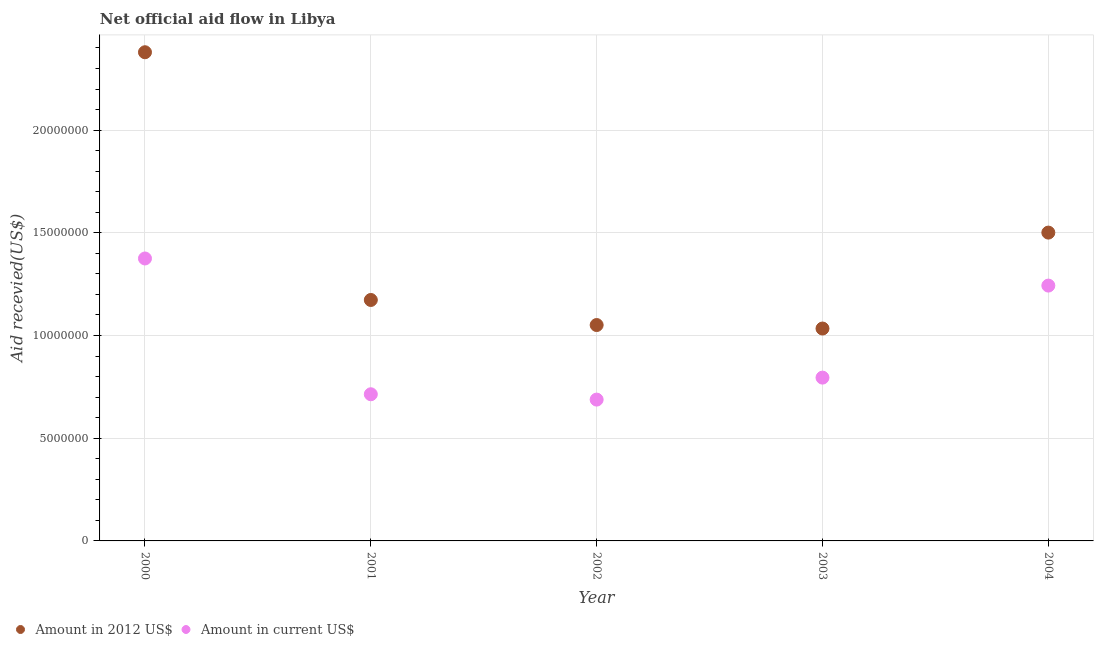How many different coloured dotlines are there?
Give a very brief answer. 2. What is the amount of aid received(expressed in us$) in 2001?
Provide a short and direct response. 7.14e+06. Across all years, what is the maximum amount of aid received(expressed in 2012 us$)?
Your response must be concise. 2.38e+07. Across all years, what is the minimum amount of aid received(expressed in us$)?
Keep it short and to the point. 6.88e+06. In which year was the amount of aid received(expressed in 2012 us$) minimum?
Provide a succinct answer. 2003. What is the total amount of aid received(expressed in us$) in the graph?
Provide a short and direct response. 4.82e+07. What is the difference between the amount of aid received(expressed in 2012 us$) in 2002 and that in 2003?
Offer a terse response. 1.70e+05. What is the difference between the amount of aid received(expressed in us$) in 2000 and the amount of aid received(expressed in 2012 us$) in 2004?
Your answer should be compact. -1.26e+06. What is the average amount of aid received(expressed in us$) per year?
Provide a succinct answer. 9.63e+06. In the year 2003, what is the difference between the amount of aid received(expressed in us$) and amount of aid received(expressed in 2012 us$)?
Offer a terse response. -2.39e+06. In how many years, is the amount of aid received(expressed in 2012 us$) greater than 14000000 US$?
Provide a short and direct response. 2. What is the ratio of the amount of aid received(expressed in 2012 us$) in 2000 to that in 2003?
Provide a short and direct response. 2.3. Is the difference between the amount of aid received(expressed in us$) in 2000 and 2002 greater than the difference between the amount of aid received(expressed in 2012 us$) in 2000 and 2002?
Your answer should be very brief. No. What is the difference between the highest and the second highest amount of aid received(expressed in 2012 us$)?
Give a very brief answer. 8.78e+06. What is the difference between the highest and the lowest amount of aid received(expressed in us$)?
Provide a succinct answer. 6.87e+06. In how many years, is the amount of aid received(expressed in 2012 us$) greater than the average amount of aid received(expressed in 2012 us$) taken over all years?
Make the answer very short. 2. Is the sum of the amount of aid received(expressed in us$) in 2001 and 2002 greater than the maximum amount of aid received(expressed in 2012 us$) across all years?
Give a very brief answer. No. Is the amount of aid received(expressed in 2012 us$) strictly greater than the amount of aid received(expressed in us$) over the years?
Your answer should be compact. Yes. Is the amount of aid received(expressed in 2012 us$) strictly less than the amount of aid received(expressed in us$) over the years?
Ensure brevity in your answer.  No. How many dotlines are there?
Ensure brevity in your answer.  2. Does the graph contain any zero values?
Offer a terse response. No. How many legend labels are there?
Your answer should be very brief. 2. What is the title of the graph?
Your answer should be very brief. Net official aid flow in Libya. Does "Highest 10% of population" appear as one of the legend labels in the graph?
Provide a succinct answer. No. What is the label or title of the X-axis?
Provide a succinct answer. Year. What is the label or title of the Y-axis?
Give a very brief answer. Aid recevied(US$). What is the Aid recevied(US$) in Amount in 2012 US$ in 2000?
Give a very brief answer. 2.38e+07. What is the Aid recevied(US$) of Amount in current US$ in 2000?
Your answer should be compact. 1.38e+07. What is the Aid recevied(US$) in Amount in 2012 US$ in 2001?
Make the answer very short. 1.17e+07. What is the Aid recevied(US$) in Amount in current US$ in 2001?
Your response must be concise. 7.14e+06. What is the Aid recevied(US$) of Amount in 2012 US$ in 2002?
Make the answer very short. 1.05e+07. What is the Aid recevied(US$) of Amount in current US$ in 2002?
Offer a very short reply. 6.88e+06. What is the Aid recevied(US$) in Amount in 2012 US$ in 2003?
Make the answer very short. 1.03e+07. What is the Aid recevied(US$) in Amount in current US$ in 2003?
Offer a very short reply. 7.95e+06. What is the Aid recevied(US$) of Amount in 2012 US$ in 2004?
Ensure brevity in your answer.  1.50e+07. What is the Aid recevied(US$) in Amount in current US$ in 2004?
Provide a short and direct response. 1.24e+07. Across all years, what is the maximum Aid recevied(US$) of Amount in 2012 US$?
Make the answer very short. 2.38e+07. Across all years, what is the maximum Aid recevied(US$) of Amount in current US$?
Make the answer very short. 1.38e+07. Across all years, what is the minimum Aid recevied(US$) in Amount in 2012 US$?
Your response must be concise. 1.03e+07. Across all years, what is the minimum Aid recevied(US$) of Amount in current US$?
Your answer should be compact. 6.88e+06. What is the total Aid recevied(US$) in Amount in 2012 US$ in the graph?
Give a very brief answer. 7.14e+07. What is the total Aid recevied(US$) in Amount in current US$ in the graph?
Keep it short and to the point. 4.82e+07. What is the difference between the Aid recevied(US$) in Amount in 2012 US$ in 2000 and that in 2001?
Your response must be concise. 1.21e+07. What is the difference between the Aid recevied(US$) of Amount in current US$ in 2000 and that in 2001?
Offer a terse response. 6.61e+06. What is the difference between the Aid recevied(US$) of Amount in 2012 US$ in 2000 and that in 2002?
Ensure brevity in your answer.  1.33e+07. What is the difference between the Aid recevied(US$) of Amount in current US$ in 2000 and that in 2002?
Make the answer very short. 6.87e+06. What is the difference between the Aid recevied(US$) of Amount in 2012 US$ in 2000 and that in 2003?
Provide a succinct answer. 1.34e+07. What is the difference between the Aid recevied(US$) of Amount in current US$ in 2000 and that in 2003?
Your answer should be compact. 5.80e+06. What is the difference between the Aid recevied(US$) in Amount in 2012 US$ in 2000 and that in 2004?
Provide a succinct answer. 8.78e+06. What is the difference between the Aid recevied(US$) in Amount in current US$ in 2000 and that in 2004?
Make the answer very short. 1.32e+06. What is the difference between the Aid recevied(US$) in Amount in 2012 US$ in 2001 and that in 2002?
Keep it short and to the point. 1.22e+06. What is the difference between the Aid recevied(US$) of Amount in current US$ in 2001 and that in 2002?
Make the answer very short. 2.60e+05. What is the difference between the Aid recevied(US$) in Amount in 2012 US$ in 2001 and that in 2003?
Your answer should be compact. 1.39e+06. What is the difference between the Aid recevied(US$) of Amount in current US$ in 2001 and that in 2003?
Provide a short and direct response. -8.10e+05. What is the difference between the Aid recevied(US$) of Amount in 2012 US$ in 2001 and that in 2004?
Your answer should be compact. -3.28e+06. What is the difference between the Aid recevied(US$) in Amount in current US$ in 2001 and that in 2004?
Offer a terse response. -5.29e+06. What is the difference between the Aid recevied(US$) of Amount in 2012 US$ in 2002 and that in 2003?
Make the answer very short. 1.70e+05. What is the difference between the Aid recevied(US$) of Amount in current US$ in 2002 and that in 2003?
Your answer should be compact. -1.07e+06. What is the difference between the Aid recevied(US$) of Amount in 2012 US$ in 2002 and that in 2004?
Offer a terse response. -4.50e+06. What is the difference between the Aid recevied(US$) of Amount in current US$ in 2002 and that in 2004?
Ensure brevity in your answer.  -5.55e+06. What is the difference between the Aid recevied(US$) of Amount in 2012 US$ in 2003 and that in 2004?
Make the answer very short. -4.67e+06. What is the difference between the Aid recevied(US$) of Amount in current US$ in 2003 and that in 2004?
Your answer should be compact. -4.48e+06. What is the difference between the Aid recevied(US$) of Amount in 2012 US$ in 2000 and the Aid recevied(US$) of Amount in current US$ in 2001?
Your answer should be compact. 1.66e+07. What is the difference between the Aid recevied(US$) in Amount in 2012 US$ in 2000 and the Aid recevied(US$) in Amount in current US$ in 2002?
Make the answer very short. 1.69e+07. What is the difference between the Aid recevied(US$) in Amount in 2012 US$ in 2000 and the Aid recevied(US$) in Amount in current US$ in 2003?
Provide a succinct answer. 1.58e+07. What is the difference between the Aid recevied(US$) of Amount in 2012 US$ in 2000 and the Aid recevied(US$) of Amount in current US$ in 2004?
Give a very brief answer. 1.14e+07. What is the difference between the Aid recevied(US$) in Amount in 2012 US$ in 2001 and the Aid recevied(US$) in Amount in current US$ in 2002?
Make the answer very short. 4.85e+06. What is the difference between the Aid recevied(US$) in Amount in 2012 US$ in 2001 and the Aid recevied(US$) in Amount in current US$ in 2003?
Your answer should be very brief. 3.78e+06. What is the difference between the Aid recevied(US$) in Amount in 2012 US$ in 2001 and the Aid recevied(US$) in Amount in current US$ in 2004?
Ensure brevity in your answer.  -7.00e+05. What is the difference between the Aid recevied(US$) in Amount in 2012 US$ in 2002 and the Aid recevied(US$) in Amount in current US$ in 2003?
Make the answer very short. 2.56e+06. What is the difference between the Aid recevied(US$) in Amount in 2012 US$ in 2002 and the Aid recevied(US$) in Amount in current US$ in 2004?
Offer a very short reply. -1.92e+06. What is the difference between the Aid recevied(US$) of Amount in 2012 US$ in 2003 and the Aid recevied(US$) of Amount in current US$ in 2004?
Ensure brevity in your answer.  -2.09e+06. What is the average Aid recevied(US$) in Amount in 2012 US$ per year?
Your answer should be very brief. 1.43e+07. What is the average Aid recevied(US$) in Amount in current US$ per year?
Ensure brevity in your answer.  9.63e+06. In the year 2000, what is the difference between the Aid recevied(US$) of Amount in 2012 US$ and Aid recevied(US$) of Amount in current US$?
Offer a very short reply. 1.00e+07. In the year 2001, what is the difference between the Aid recevied(US$) of Amount in 2012 US$ and Aid recevied(US$) of Amount in current US$?
Keep it short and to the point. 4.59e+06. In the year 2002, what is the difference between the Aid recevied(US$) in Amount in 2012 US$ and Aid recevied(US$) in Amount in current US$?
Make the answer very short. 3.63e+06. In the year 2003, what is the difference between the Aid recevied(US$) of Amount in 2012 US$ and Aid recevied(US$) of Amount in current US$?
Keep it short and to the point. 2.39e+06. In the year 2004, what is the difference between the Aid recevied(US$) in Amount in 2012 US$ and Aid recevied(US$) in Amount in current US$?
Your answer should be very brief. 2.58e+06. What is the ratio of the Aid recevied(US$) in Amount in 2012 US$ in 2000 to that in 2001?
Your answer should be compact. 2.03. What is the ratio of the Aid recevied(US$) in Amount in current US$ in 2000 to that in 2001?
Make the answer very short. 1.93. What is the ratio of the Aid recevied(US$) of Amount in 2012 US$ in 2000 to that in 2002?
Make the answer very short. 2.26. What is the ratio of the Aid recevied(US$) of Amount in current US$ in 2000 to that in 2002?
Make the answer very short. 2. What is the ratio of the Aid recevied(US$) in Amount in 2012 US$ in 2000 to that in 2003?
Provide a succinct answer. 2.3. What is the ratio of the Aid recevied(US$) of Amount in current US$ in 2000 to that in 2003?
Your answer should be compact. 1.73. What is the ratio of the Aid recevied(US$) of Amount in 2012 US$ in 2000 to that in 2004?
Provide a short and direct response. 1.58. What is the ratio of the Aid recevied(US$) of Amount in current US$ in 2000 to that in 2004?
Ensure brevity in your answer.  1.11. What is the ratio of the Aid recevied(US$) of Amount in 2012 US$ in 2001 to that in 2002?
Your answer should be compact. 1.12. What is the ratio of the Aid recevied(US$) in Amount in current US$ in 2001 to that in 2002?
Provide a short and direct response. 1.04. What is the ratio of the Aid recevied(US$) of Amount in 2012 US$ in 2001 to that in 2003?
Your response must be concise. 1.13. What is the ratio of the Aid recevied(US$) in Amount in current US$ in 2001 to that in 2003?
Keep it short and to the point. 0.9. What is the ratio of the Aid recevied(US$) in Amount in 2012 US$ in 2001 to that in 2004?
Provide a short and direct response. 0.78. What is the ratio of the Aid recevied(US$) in Amount in current US$ in 2001 to that in 2004?
Keep it short and to the point. 0.57. What is the ratio of the Aid recevied(US$) of Amount in 2012 US$ in 2002 to that in 2003?
Offer a very short reply. 1.02. What is the ratio of the Aid recevied(US$) of Amount in current US$ in 2002 to that in 2003?
Give a very brief answer. 0.87. What is the ratio of the Aid recevied(US$) in Amount in 2012 US$ in 2002 to that in 2004?
Your response must be concise. 0.7. What is the ratio of the Aid recevied(US$) of Amount in current US$ in 2002 to that in 2004?
Keep it short and to the point. 0.55. What is the ratio of the Aid recevied(US$) in Amount in 2012 US$ in 2003 to that in 2004?
Offer a very short reply. 0.69. What is the ratio of the Aid recevied(US$) in Amount in current US$ in 2003 to that in 2004?
Your answer should be very brief. 0.64. What is the difference between the highest and the second highest Aid recevied(US$) in Amount in 2012 US$?
Keep it short and to the point. 8.78e+06. What is the difference between the highest and the second highest Aid recevied(US$) in Amount in current US$?
Ensure brevity in your answer.  1.32e+06. What is the difference between the highest and the lowest Aid recevied(US$) in Amount in 2012 US$?
Your answer should be very brief. 1.34e+07. What is the difference between the highest and the lowest Aid recevied(US$) in Amount in current US$?
Keep it short and to the point. 6.87e+06. 